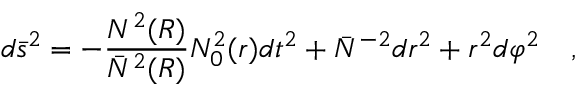<formula> <loc_0><loc_0><loc_500><loc_500>d \bar { s } ^ { 2 } = - { \frac { N ^ { 2 } ( R ) } { \bar { N } ^ { 2 } ( R ) } } N _ { 0 } ^ { 2 } ( r ) d t ^ { 2 } + \bar { N } ^ { - 2 } d r ^ { 2 } + r ^ { 2 } d \varphi ^ { 2 } ,</formula> 